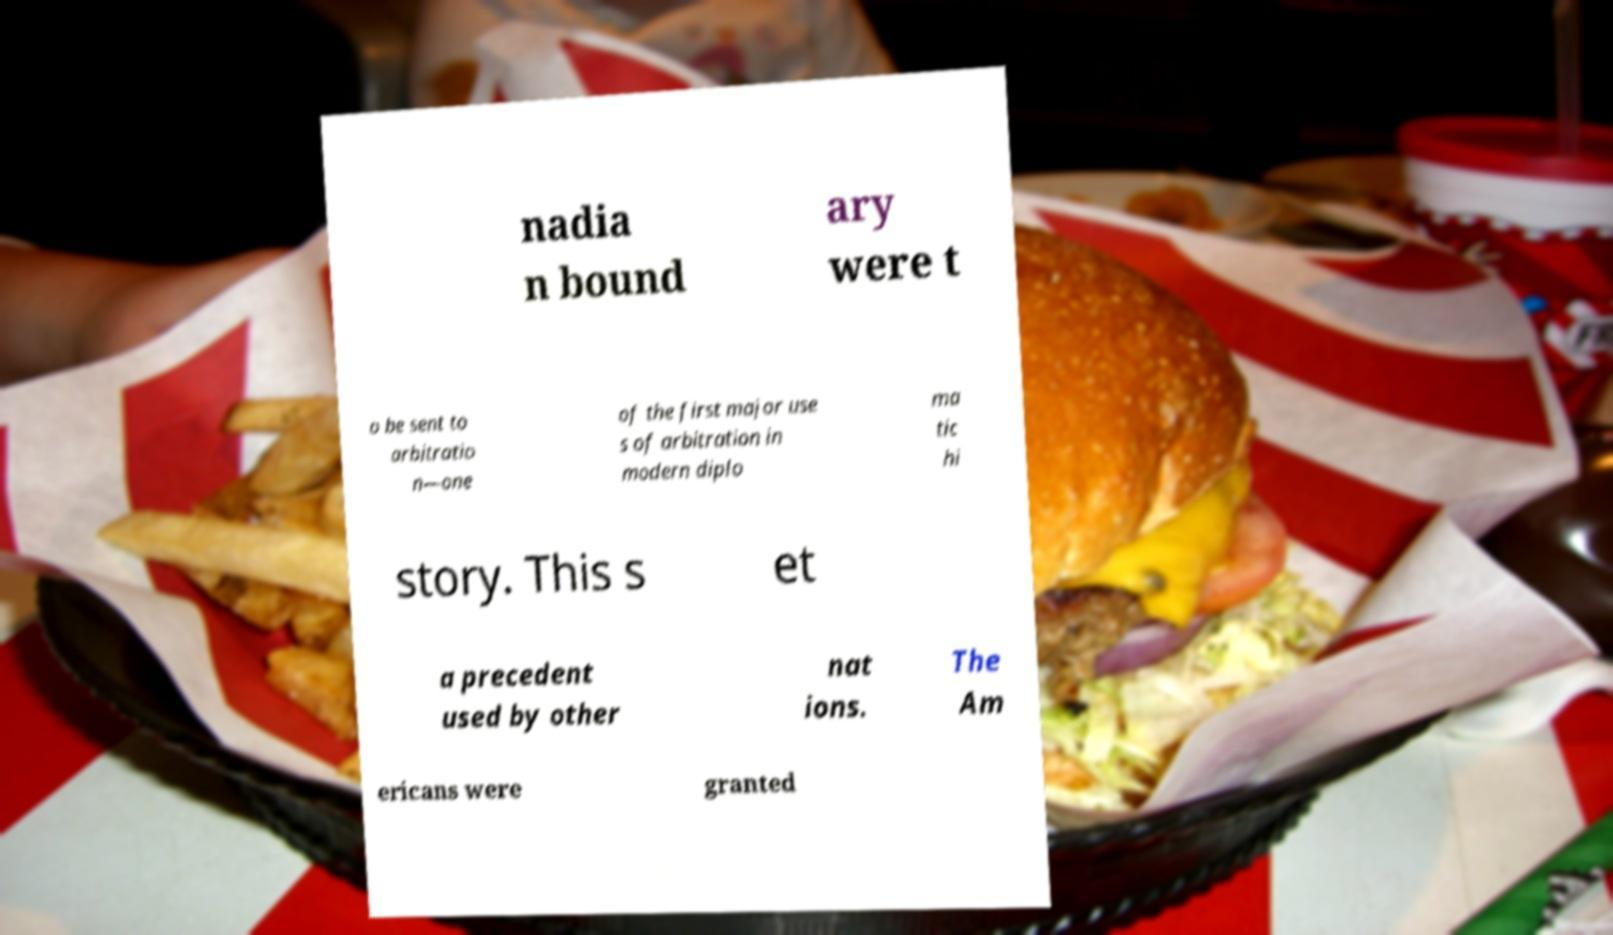Can you accurately transcribe the text from the provided image for me? nadia n bound ary were t o be sent to arbitratio n—one of the first major use s of arbitration in modern diplo ma tic hi story. This s et a precedent used by other nat ions. The Am ericans were granted 